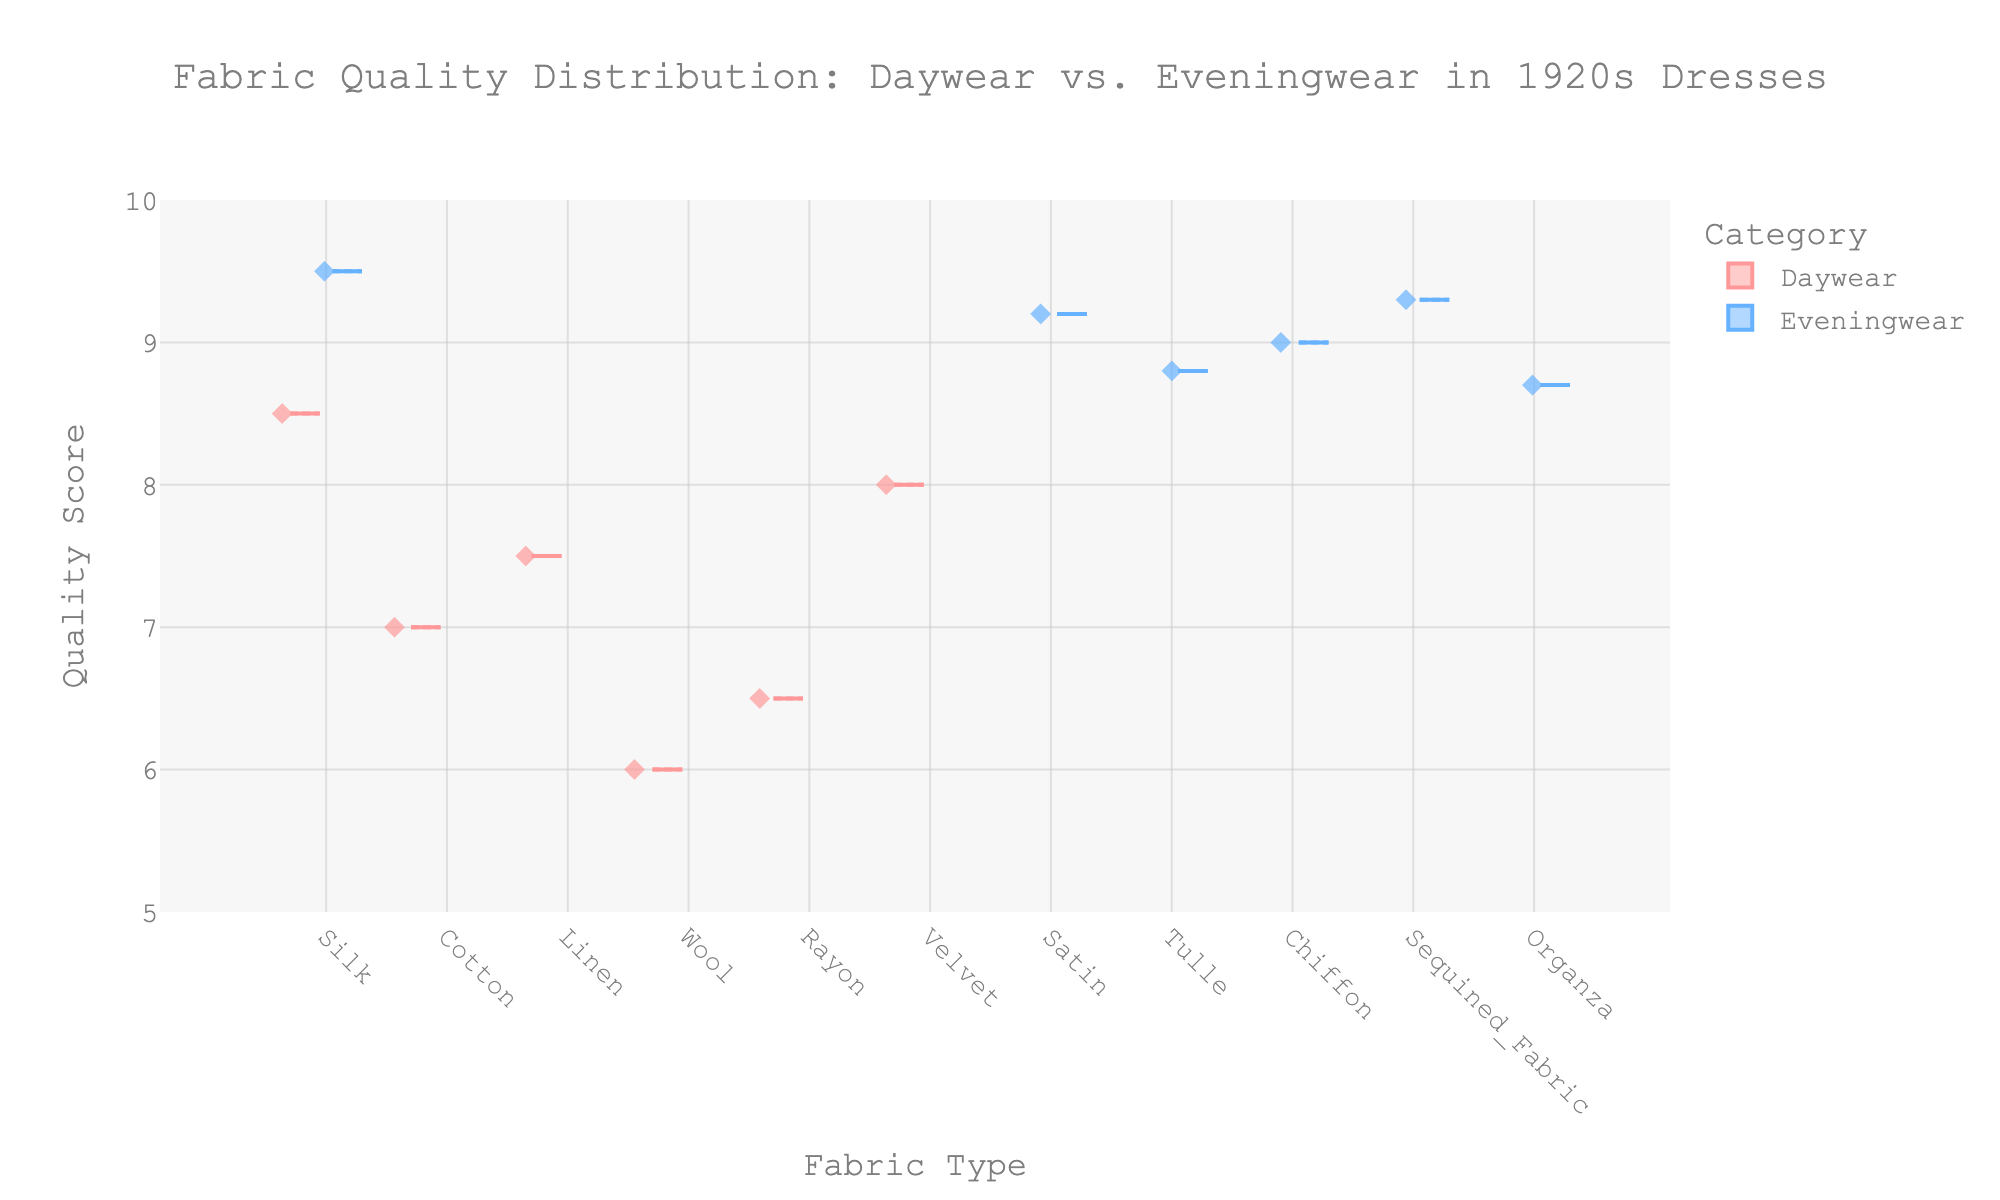What is the title of the plot? The title is typically displayed at the top of the plot. In this case, the title is "Fabric Quality Distribution: Daywear vs. Eveningwear in 1920s Dresses."
Answer: Fabric Quality Distribution: Daywear vs. Eveningwear in 1920s Dresses What are the categories being compared in the plot? The categories are mentioned in the legend of the plot, with colors distinguishing them. Here, two categories are being compared: "Daywear" and "Eveningwear."
Answer: Daywear and Eveningwear Which fabric type has the highest quality score in daywear? From the figure, look for the daywear box plot with the highest position on the y-axis. In this case, "Silk" has the highest quality score in daywear.
Answer: Silk What is the median quality score for Eveningwear? In a box plot, the median is indicated by the line inside the box. Look for the median line within the Eveningwear box plots. On average, the median for Eveningwear quality scores is approximately 9.1.
Answer: 9.1 Which category shows a higher dispersion in quality scores? The dispersion or spread can be seen by the length of the box and the whiskers. Daywear shows a higher dispersion in quality scores as the whiskers and box for Daywear are spread out more widely compared to Eveningwear.
Answer: Daywear What is the mean quality score for Daywear fabrics? The mean is shown by the symbol 'X' in the box plot. For Daywear fabrics, find the average position on the y-axis representing the mean quality score. It is around 7.0.
Answer: 7.0 Is the quality score for Velvet higher in Daywear or Eveningwear? Velvet only appears in the Daywear category. Thus, compare the position of the velvet box plot or dot to the median/mean line of Eveningwear. In this case, Velvet only has a quality score of 8.0 in Daywear and is not listed in Eveningwear.
Answer: Daywear Which fabric type has the lowest quality score in daywear? Look for the lowest point in the Daywear category on the y-axis. Wool has the lowest quality score among Daywear fabrics, at a score of 6.0.
Answer: Wool Are there any fabrics that are only used in one category and not the other? Check each fabric type to see if it appears in only one category (Daywear or Eveningwear). Fabrics like Cotton, Linen, Wool, Velvet, Rayon are used only in Daywear, while Satin, Tulle, Chiffon, Sequined Fabric, and Organza appear only in Eveningwear.
Answer: Yes Which fabric in Eveningwear has the highest interquartile range (IQR)? The IQR in a box plot is the range within the box from Q1 to Q3. Compare the height of the boxes for Eveningwear fabrics. Sequined Fabric has the widest box, indicating the highest IQR.
Answer: Sequined Fabric 